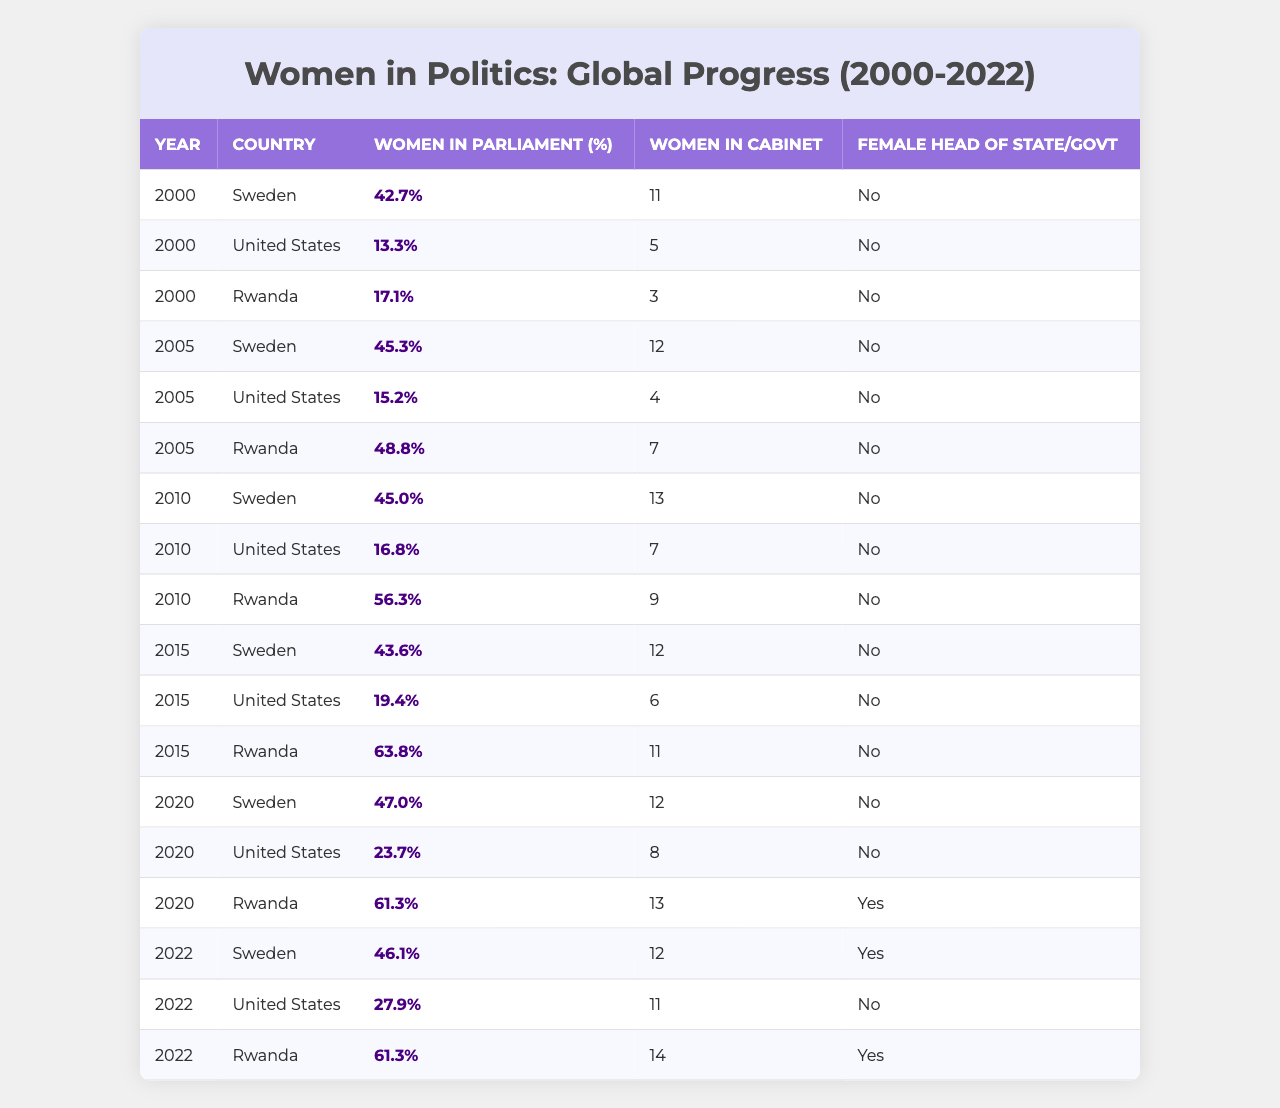What was the percentage of women in parliament in Rwanda in 2010? From the table, we look at the row for the year 2010 and find Rwanda, which shows a percentage of women in parliament as 56.3%.
Answer: 56.3% How many women were in cabinet positions in the United States in 2015? Referring to the row for the year 2015, we find the United States and see that the number of women in cabinet positions is 6.
Answer: 6 Which country had the highest percentage of women in parliament in 2020? In the 2020 data rows, we compare the percentages of women in parliament across Sweden, the United States, and Rwanda. Rwanda has the highest percentage at 61.3%.
Answer: Rwanda Did Sweden ever have a female head of state or government from 2000 to 2022? Looking through the rows for Sweden from 2000 to 2022, none of the entries indicate that Sweden had a female head of state or government; all entries are marked "No."
Answer: No What was the trend of the percentage of women in parliament in Sweden from 2000 to 2022? To determine the trend, we observe the percentages: 42.7% (2000), 45.3% (2005), 45.0% (2010), 43.6% (2015), 47.0% (2020), and 46.1% (2022). Analyzing these values, we see slight fluctuations, but the overall trend is relatively stable with a slight increase towards the latest years.
Answer: Relatively stable with a slight increase What is the difference in the number of women in cabinet positions between Rwanda in 2005 and Sweden in 2020? We find the number of women in cabinet positions for Rwanda in 2005, which is 7, and for Sweden in 2020, which is 12. The difference is calculated as 12 - 7 = 5.
Answer: 5 What was the average percentage of women in parliament across the three countries in 2010? To find the average, we take the percentages from the year 2010: 45.0% (Sweden), 16.8% (United States), and 56.3% (Rwanda). The sum is 45.0 + 16.8 + 56.3 = 118.1, divided by 3 gives an average of 39.37%.
Answer: 39.37% Did Rwanda have any female head of state or government in 2020? Checking the 2020 row for Rwanda, we see it is marked "Yes" for having a female head of state or government.
Answer: Yes In which year did the United States see the largest increase in the percentage of women in parliament? By reviewing the percentages for the United States: 13.3% (2000), 15.2% (2005), 16.8% (2010), 19.4% (2015), 23.7% (2020), and 27.9% (2022), the largest increase occurs between 2015 (19.4%) and 2020 (23.7%), which is an increase of 4.3%.
Answer: 2020 What is the total number of women in cabinet positions across all years for Rwanda? Reviewing the rows for Rwanda, we find the numbers: 3 (2000), 7 (2005), 9 (2010), 11 (2015), 13 (2020), and 14 (2022). Adding these gives 3 + 7 + 9 + 11 + 13 + 14 = 57.
Answer: 57 How many total years did Sweden have a female head of state or government from 2000 to 2022? Looking through Sweden's data from 2000 to 2022, every entry indicates "No" for having a female head of state or government. Thus, the total is 0 years.
Answer: 0 